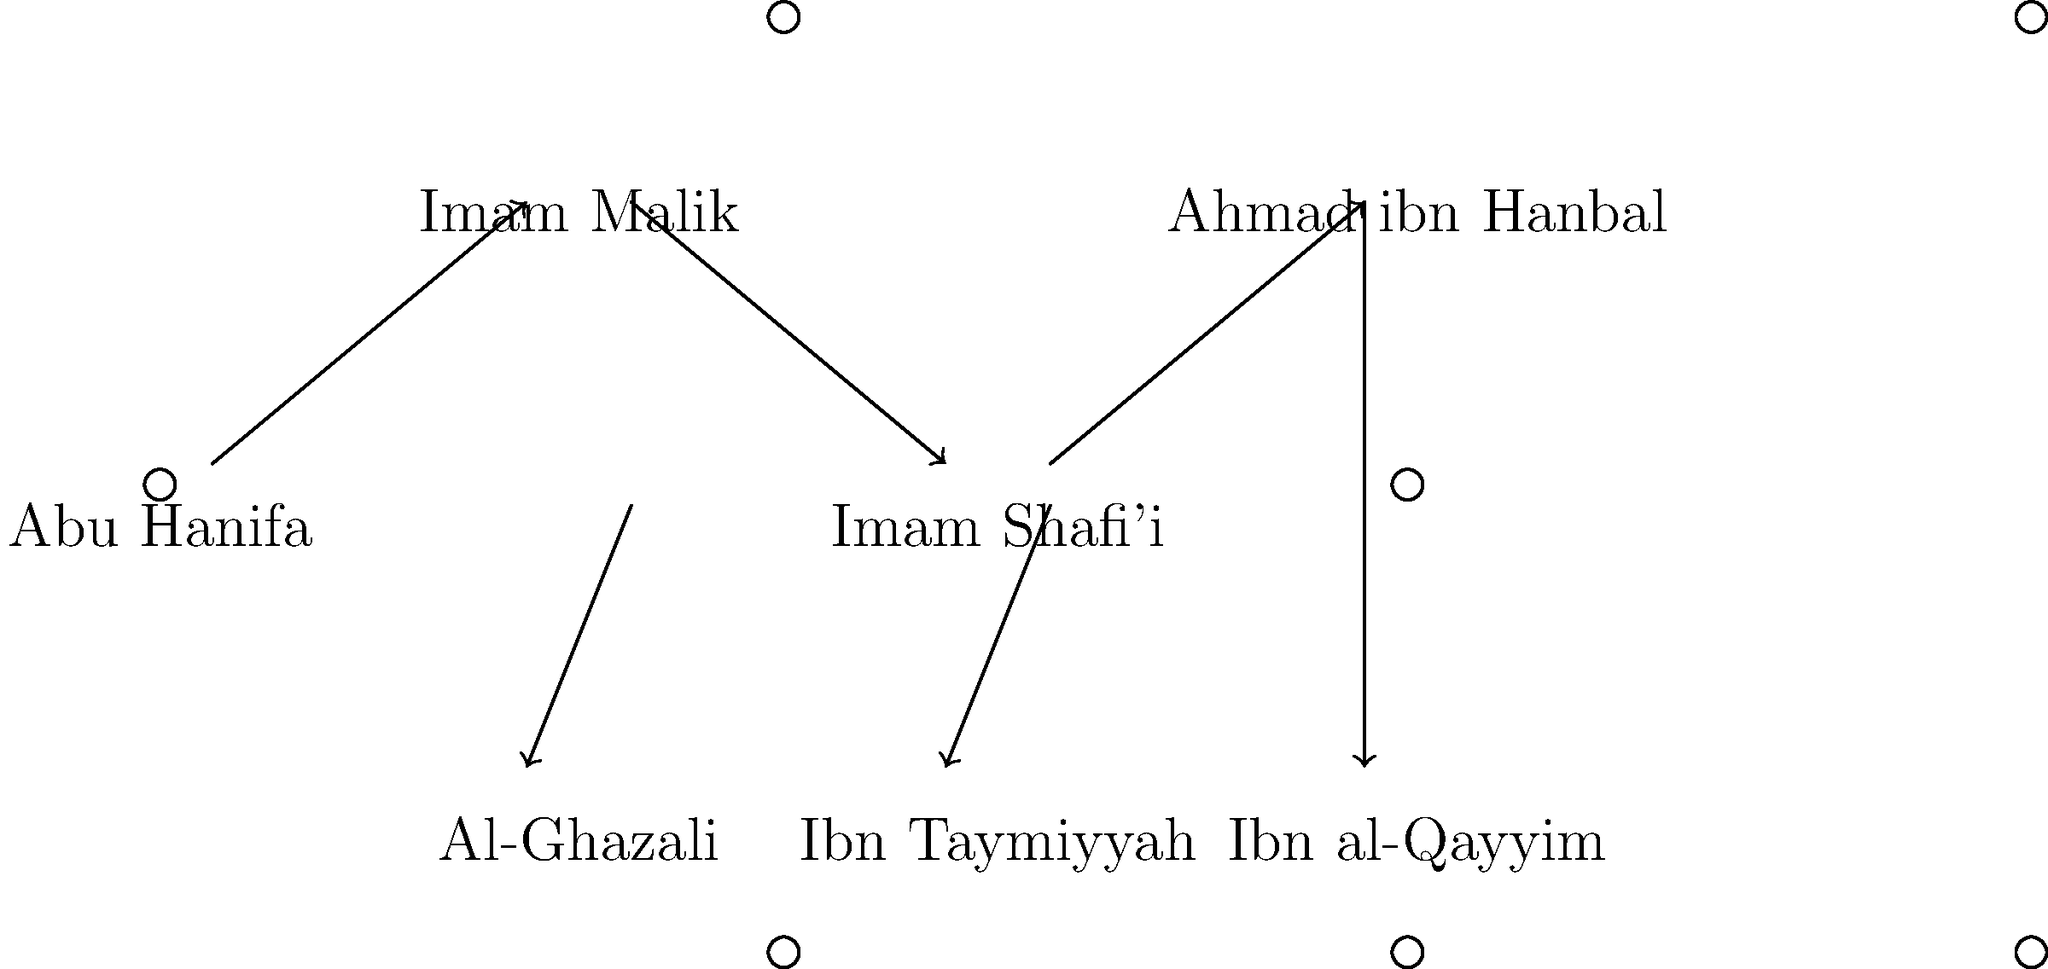Based on the genealogy diagram of prominent Muslim scholars, which scholar is directly connected to both Al-Ghazali and Ibn Taymiyyah, representing a bridge between different schools of thought? To answer this question, let's analyze the diagram step-by-step:

1. The diagram shows a genealogy of prominent Muslim scholars from different schools of thought.

2. We can see the following scholars represented:
   - Abu Hanifa
   - Imam Malik
   - Imam Shafi'i
   - Ahmad ibn Hanbal
   - Al-Ghazali
   - Ibn Taymiyyah
   - Ibn al-Qayyim

3. The arrows in the diagram represent intellectual or scholarly connections between the scholars.

4. We need to find a scholar that has direct connections to both Al-Ghazali and Ibn Taymiyyah.

5. Looking at the diagram, we can see that:
   - Al-Ghazali is connected to Imam Shafi'i
   - Ibn Taymiyyah is also connected to Imam Shafi'i

6. Therefore, Imam Shafi'i serves as the bridge between Al-Ghazali and Ibn Taymiyyah, representing a connection between different schools of thought.

This connection is significant because Imam Shafi'i is known for his role in synthesizing and reconciling different Islamic legal traditions, which is reflected in his position in the diagram.
Answer: Imam Shafi'i 